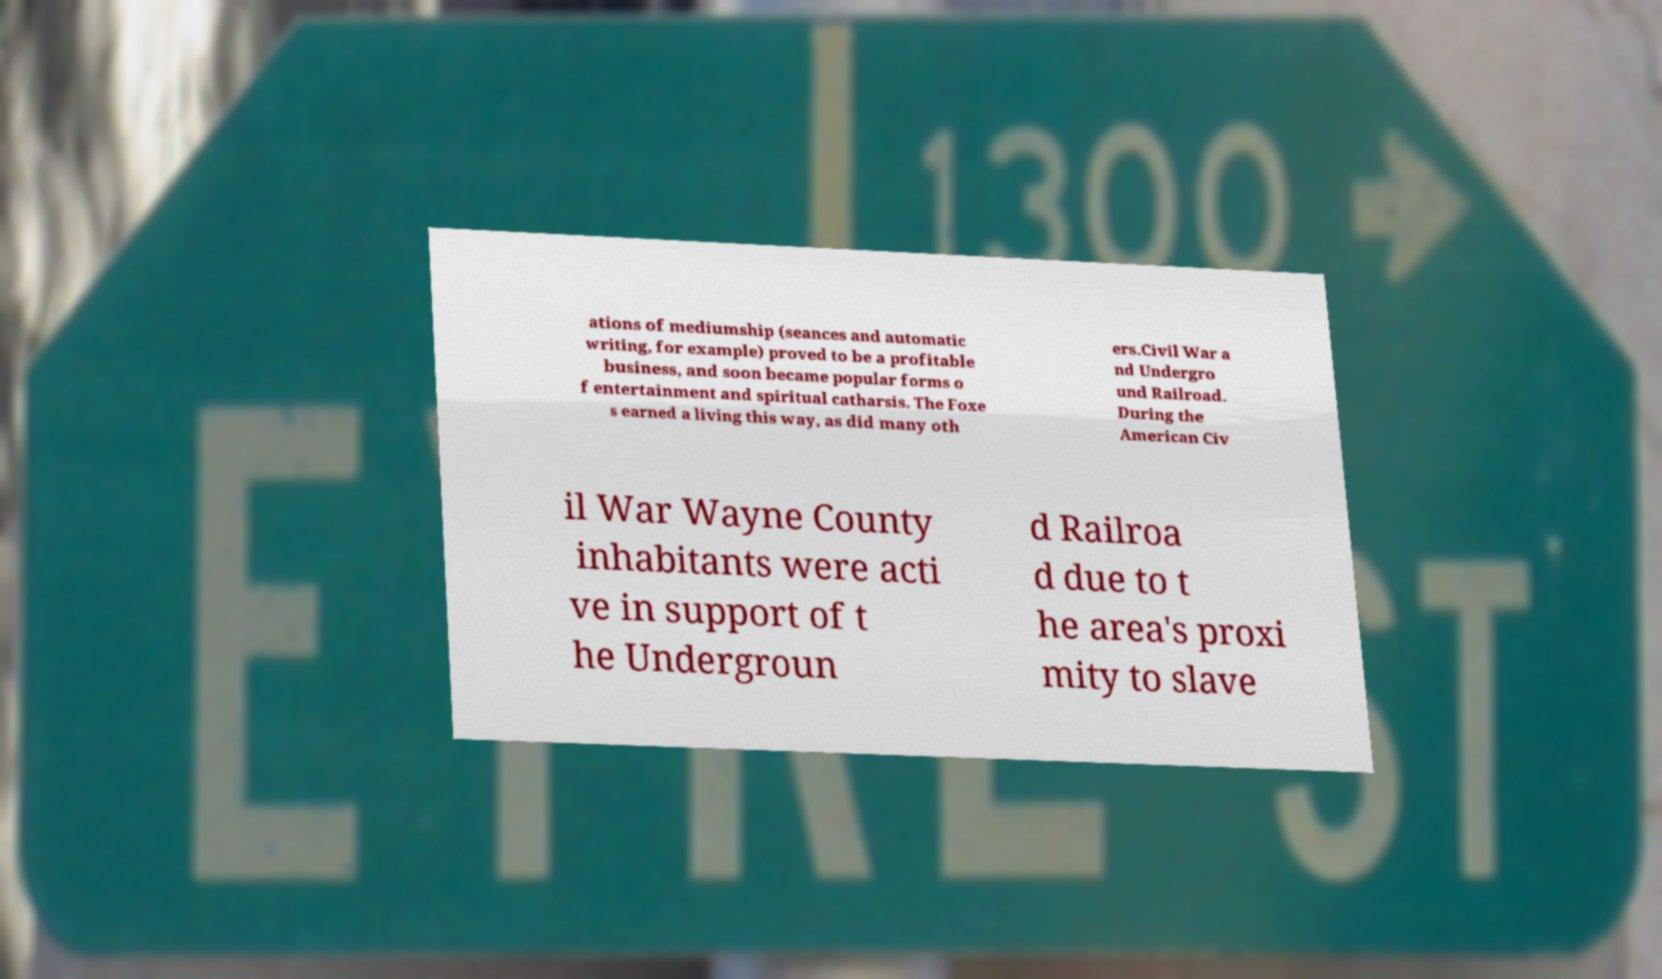Could you assist in decoding the text presented in this image and type it out clearly? ations of mediumship (seances and automatic writing, for example) proved to be a profitable business, and soon became popular forms o f entertainment and spiritual catharsis. The Foxe s earned a living this way, as did many oth ers.Civil War a nd Undergro und Railroad. During the American Civ il War Wayne County inhabitants were acti ve in support of t he Undergroun d Railroa d due to t he area's proxi mity to slave 